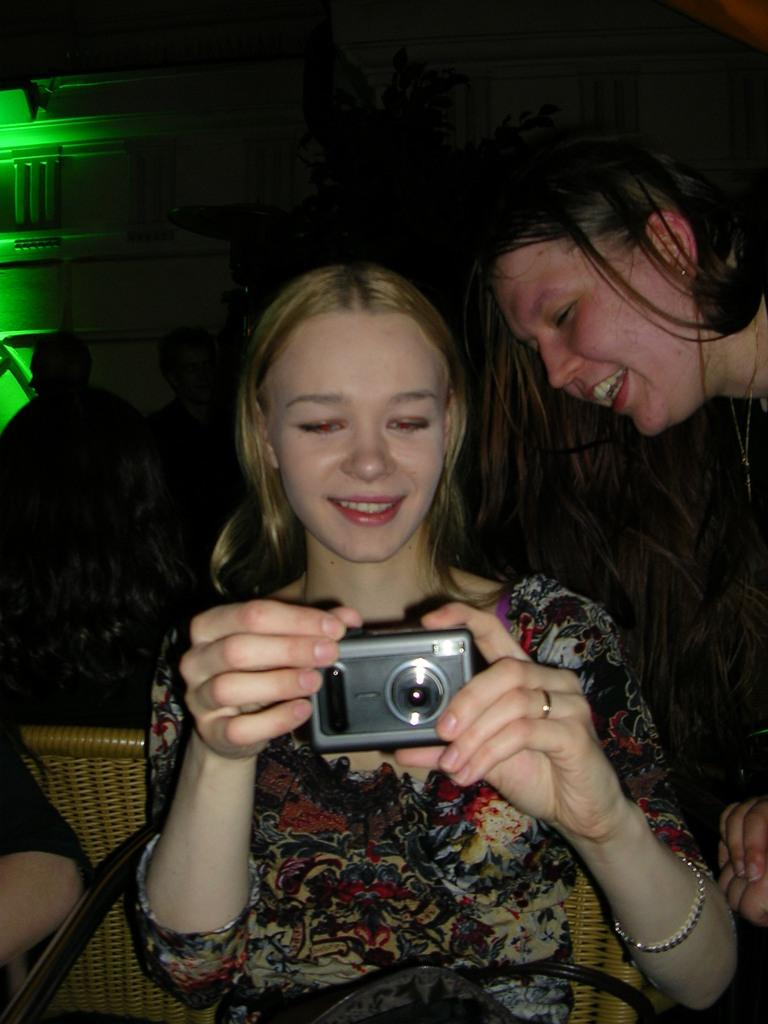What is the woman in the image doing? The woman is sitting in a chair and clicking a picture. What is the woman holding in the image? The woman is holding a camera. What is the expression on the woman's face? The woman is smiling. Is there anyone else in the image? Yes, there is another woman beside her. What type of wood is the laborer using to recite a verse in the image? There is no laborer or wood present in the image, and no one is reciting a verse. 